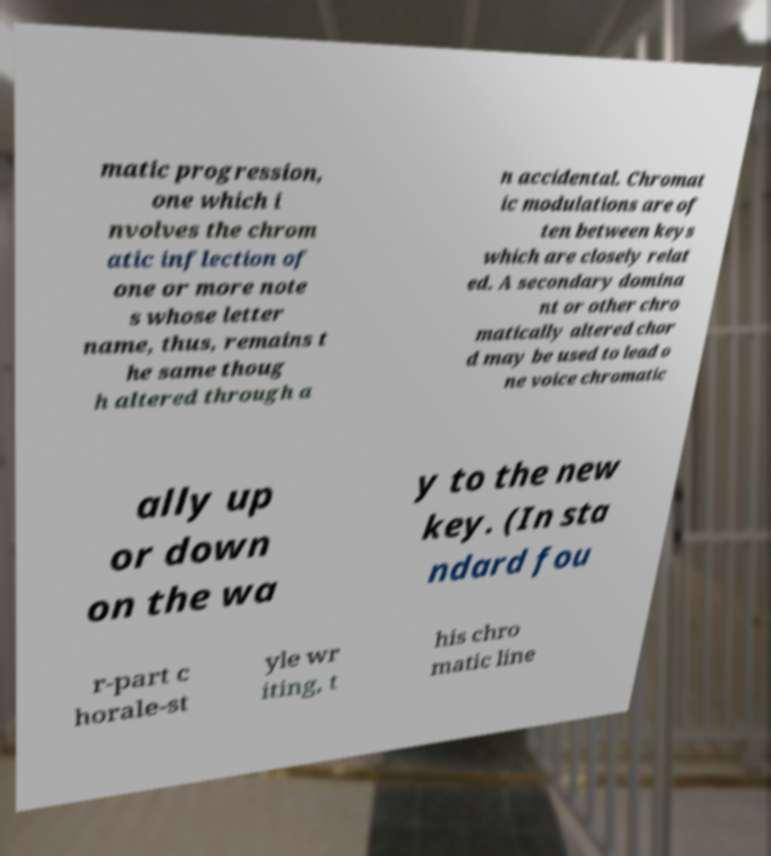Can you accurately transcribe the text from the provided image for me? matic progression, one which i nvolves the chrom atic inflection of one or more note s whose letter name, thus, remains t he same thoug h altered through a n accidental. Chromat ic modulations are of ten between keys which are closely relat ed. A secondary domina nt or other chro matically altered chor d may be used to lead o ne voice chromatic ally up or down on the wa y to the new key. (In sta ndard fou r-part c horale-st yle wr iting, t his chro matic line 